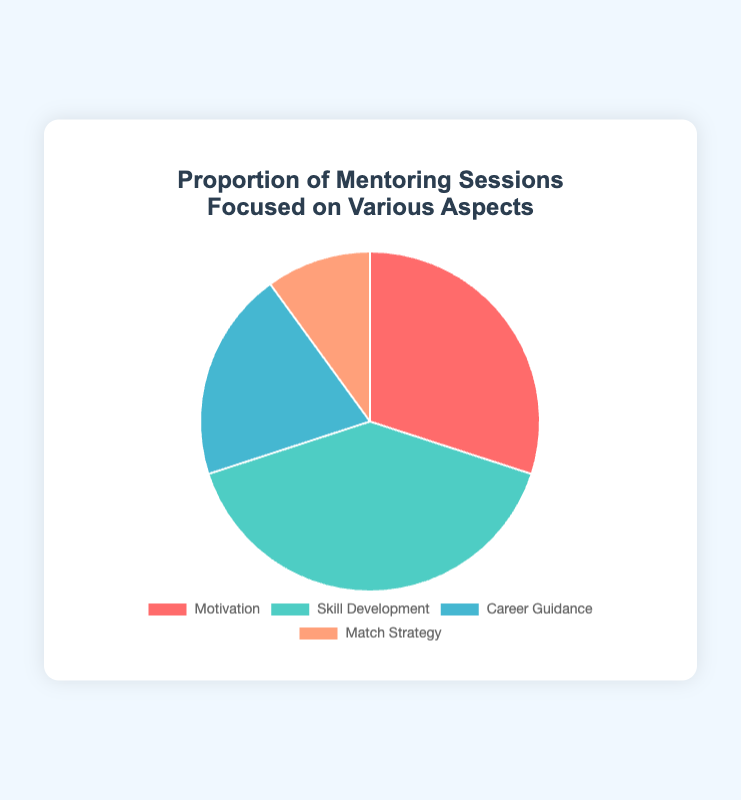What percentage of mentoring sessions are focused on Motivation? According to the pie chart, the section labeled 'Motivation' represents 30% of the mentoring sessions.
Answer: 30% Which aspect has the highest proportion of mentoring sessions? By comparing the proportions of each aspect, 'Skill Development' has the largest section, indicating the highest percentage, which is 40%.
Answer: Skill Development How much more focus is given to Skill Development than to Match Strategy? Skill Development represents 40% of the mentoring sessions, while Match Strategy represents 10%. The difference is 40% - 10% = 30%.
Answer: 30% What is the combined percentage of sessions focused on Career Guidance and Match Strategy? Career Guidance accounts for 20% and Match Strategy for 10%. Adding these together gives 20% + 10% = 30%.
Answer: 30% If you combined the mentoring sessions focused on Motivation and Skill Development, what fraction of the total sessions would it represent? Motivation accounts for 30% and Skill Development 40%, combining them gives 30% + 40% = 70%. This represents 70% of the total sessions.
Answer: 70% What is the ratio of sessions focused on Career Guidance to those on Motivation? Career Guidance is 20% and Motivation is 30%. The ratio is 20% to 30%, which simplifies to 2:3.
Answer: 2:3 Among the given aspects, which has the smallest representation in the mentoring sessions? By looking at the sizes of the sections, the smallest section is 'Match Strategy' which represents 10%.
Answer: Match Strategy By how much does the proportion of Skill Development exceed the average proportion of all four aspects? The average proportion is calculated as (30% + 40% + 20% + 10%) / 4 = 25%. Skill Development's proportion is 40%. The excess is 40% - 25% = 15%.
Answer: 15% Which two aspects, when combined, make up half of the mentoring sessions? Skill Development (40%) and Career Guidance (20%) together amount to 60%, which exceeds half. Instead, Motivation (30%) and Career Guidance (20%) together form 50%.
Answer: Motivation and Career Guidance 